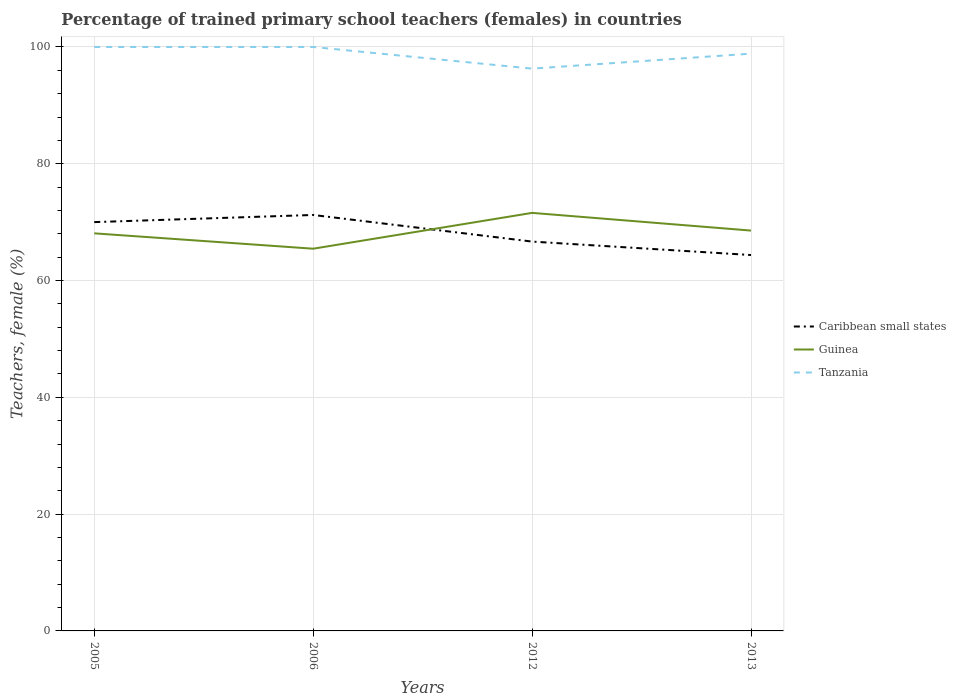Across all years, what is the maximum percentage of trained primary school teachers (females) in Tanzania?
Keep it short and to the point. 96.29. In which year was the percentage of trained primary school teachers (females) in Caribbean small states maximum?
Offer a terse response. 2013. What is the total percentage of trained primary school teachers (females) in Tanzania in the graph?
Provide a short and direct response. 1.14. What is the difference between the highest and the second highest percentage of trained primary school teachers (females) in Tanzania?
Ensure brevity in your answer.  3.71. How many lines are there?
Provide a succinct answer. 3. What is the difference between two consecutive major ticks on the Y-axis?
Give a very brief answer. 20. Are the values on the major ticks of Y-axis written in scientific E-notation?
Offer a terse response. No. Does the graph contain any zero values?
Provide a succinct answer. No. Does the graph contain grids?
Your response must be concise. Yes. How many legend labels are there?
Make the answer very short. 3. How are the legend labels stacked?
Keep it short and to the point. Vertical. What is the title of the graph?
Offer a very short reply. Percentage of trained primary school teachers (females) in countries. What is the label or title of the X-axis?
Provide a short and direct response. Years. What is the label or title of the Y-axis?
Offer a terse response. Teachers, female (%). What is the Teachers, female (%) of Caribbean small states in 2005?
Offer a terse response. 70.01. What is the Teachers, female (%) of Guinea in 2005?
Your answer should be compact. 68.08. What is the Teachers, female (%) in Tanzania in 2005?
Give a very brief answer. 100. What is the Teachers, female (%) of Caribbean small states in 2006?
Offer a very short reply. 71.23. What is the Teachers, female (%) in Guinea in 2006?
Your answer should be compact. 65.45. What is the Teachers, female (%) in Caribbean small states in 2012?
Offer a very short reply. 66.67. What is the Teachers, female (%) in Guinea in 2012?
Provide a succinct answer. 71.59. What is the Teachers, female (%) in Tanzania in 2012?
Your response must be concise. 96.29. What is the Teachers, female (%) in Caribbean small states in 2013?
Provide a succinct answer. 64.37. What is the Teachers, female (%) in Guinea in 2013?
Your answer should be very brief. 68.56. What is the Teachers, female (%) of Tanzania in 2013?
Provide a short and direct response. 98.86. Across all years, what is the maximum Teachers, female (%) in Caribbean small states?
Offer a terse response. 71.23. Across all years, what is the maximum Teachers, female (%) of Guinea?
Offer a very short reply. 71.59. Across all years, what is the minimum Teachers, female (%) in Caribbean small states?
Your answer should be compact. 64.37. Across all years, what is the minimum Teachers, female (%) in Guinea?
Your response must be concise. 65.45. Across all years, what is the minimum Teachers, female (%) of Tanzania?
Your answer should be compact. 96.29. What is the total Teachers, female (%) of Caribbean small states in the graph?
Offer a terse response. 272.29. What is the total Teachers, female (%) in Guinea in the graph?
Provide a succinct answer. 273.69. What is the total Teachers, female (%) in Tanzania in the graph?
Make the answer very short. 395.15. What is the difference between the Teachers, female (%) in Caribbean small states in 2005 and that in 2006?
Keep it short and to the point. -1.22. What is the difference between the Teachers, female (%) of Guinea in 2005 and that in 2006?
Give a very brief answer. 2.63. What is the difference between the Teachers, female (%) in Tanzania in 2005 and that in 2006?
Offer a terse response. 0. What is the difference between the Teachers, female (%) of Caribbean small states in 2005 and that in 2012?
Make the answer very short. 3.33. What is the difference between the Teachers, female (%) in Guinea in 2005 and that in 2012?
Keep it short and to the point. -3.5. What is the difference between the Teachers, female (%) of Tanzania in 2005 and that in 2012?
Provide a short and direct response. 3.71. What is the difference between the Teachers, female (%) of Caribbean small states in 2005 and that in 2013?
Provide a succinct answer. 5.64. What is the difference between the Teachers, female (%) in Guinea in 2005 and that in 2013?
Your answer should be very brief. -0.47. What is the difference between the Teachers, female (%) in Tanzania in 2005 and that in 2013?
Provide a short and direct response. 1.14. What is the difference between the Teachers, female (%) of Caribbean small states in 2006 and that in 2012?
Provide a short and direct response. 4.56. What is the difference between the Teachers, female (%) of Guinea in 2006 and that in 2012?
Your response must be concise. -6.13. What is the difference between the Teachers, female (%) in Tanzania in 2006 and that in 2012?
Ensure brevity in your answer.  3.71. What is the difference between the Teachers, female (%) in Caribbean small states in 2006 and that in 2013?
Offer a very short reply. 6.86. What is the difference between the Teachers, female (%) in Guinea in 2006 and that in 2013?
Provide a succinct answer. -3.1. What is the difference between the Teachers, female (%) of Tanzania in 2006 and that in 2013?
Make the answer very short. 1.14. What is the difference between the Teachers, female (%) in Caribbean small states in 2012 and that in 2013?
Ensure brevity in your answer.  2.3. What is the difference between the Teachers, female (%) of Guinea in 2012 and that in 2013?
Ensure brevity in your answer.  3.03. What is the difference between the Teachers, female (%) in Tanzania in 2012 and that in 2013?
Provide a succinct answer. -2.57. What is the difference between the Teachers, female (%) of Caribbean small states in 2005 and the Teachers, female (%) of Guinea in 2006?
Offer a terse response. 4.55. What is the difference between the Teachers, female (%) in Caribbean small states in 2005 and the Teachers, female (%) in Tanzania in 2006?
Make the answer very short. -29.99. What is the difference between the Teachers, female (%) of Guinea in 2005 and the Teachers, female (%) of Tanzania in 2006?
Provide a succinct answer. -31.92. What is the difference between the Teachers, female (%) of Caribbean small states in 2005 and the Teachers, female (%) of Guinea in 2012?
Keep it short and to the point. -1.58. What is the difference between the Teachers, female (%) of Caribbean small states in 2005 and the Teachers, female (%) of Tanzania in 2012?
Give a very brief answer. -26.28. What is the difference between the Teachers, female (%) in Guinea in 2005 and the Teachers, female (%) in Tanzania in 2012?
Ensure brevity in your answer.  -28.21. What is the difference between the Teachers, female (%) of Caribbean small states in 2005 and the Teachers, female (%) of Guinea in 2013?
Make the answer very short. 1.45. What is the difference between the Teachers, female (%) of Caribbean small states in 2005 and the Teachers, female (%) of Tanzania in 2013?
Offer a terse response. -28.85. What is the difference between the Teachers, female (%) in Guinea in 2005 and the Teachers, female (%) in Tanzania in 2013?
Your answer should be compact. -30.77. What is the difference between the Teachers, female (%) in Caribbean small states in 2006 and the Teachers, female (%) in Guinea in 2012?
Your answer should be compact. -0.36. What is the difference between the Teachers, female (%) in Caribbean small states in 2006 and the Teachers, female (%) in Tanzania in 2012?
Your answer should be compact. -25.06. What is the difference between the Teachers, female (%) in Guinea in 2006 and the Teachers, female (%) in Tanzania in 2012?
Offer a very short reply. -30.84. What is the difference between the Teachers, female (%) of Caribbean small states in 2006 and the Teachers, female (%) of Guinea in 2013?
Your response must be concise. 2.67. What is the difference between the Teachers, female (%) in Caribbean small states in 2006 and the Teachers, female (%) in Tanzania in 2013?
Your answer should be compact. -27.62. What is the difference between the Teachers, female (%) in Guinea in 2006 and the Teachers, female (%) in Tanzania in 2013?
Your response must be concise. -33.4. What is the difference between the Teachers, female (%) in Caribbean small states in 2012 and the Teachers, female (%) in Guinea in 2013?
Offer a very short reply. -1.88. What is the difference between the Teachers, female (%) in Caribbean small states in 2012 and the Teachers, female (%) in Tanzania in 2013?
Provide a short and direct response. -32.18. What is the difference between the Teachers, female (%) of Guinea in 2012 and the Teachers, female (%) of Tanzania in 2013?
Provide a short and direct response. -27.27. What is the average Teachers, female (%) in Caribbean small states per year?
Your answer should be very brief. 68.07. What is the average Teachers, female (%) in Guinea per year?
Provide a succinct answer. 68.42. What is the average Teachers, female (%) in Tanzania per year?
Ensure brevity in your answer.  98.79. In the year 2005, what is the difference between the Teachers, female (%) of Caribbean small states and Teachers, female (%) of Guinea?
Offer a very short reply. 1.92. In the year 2005, what is the difference between the Teachers, female (%) in Caribbean small states and Teachers, female (%) in Tanzania?
Your answer should be compact. -29.99. In the year 2005, what is the difference between the Teachers, female (%) in Guinea and Teachers, female (%) in Tanzania?
Provide a succinct answer. -31.92. In the year 2006, what is the difference between the Teachers, female (%) of Caribbean small states and Teachers, female (%) of Guinea?
Your answer should be very brief. 5.78. In the year 2006, what is the difference between the Teachers, female (%) of Caribbean small states and Teachers, female (%) of Tanzania?
Give a very brief answer. -28.77. In the year 2006, what is the difference between the Teachers, female (%) of Guinea and Teachers, female (%) of Tanzania?
Provide a short and direct response. -34.55. In the year 2012, what is the difference between the Teachers, female (%) of Caribbean small states and Teachers, female (%) of Guinea?
Offer a terse response. -4.92. In the year 2012, what is the difference between the Teachers, female (%) of Caribbean small states and Teachers, female (%) of Tanzania?
Ensure brevity in your answer.  -29.62. In the year 2012, what is the difference between the Teachers, female (%) in Guinea and Teachers, female (%) in Tanzania?
Offer a very short reply. -24.7. In the year 2013, what is the difference between the Teachers, female (%) of Caribbean small states and Teachers, female (%) of Guinea?
Your answer should be very brief. -4.19. In the year 2013, what is the difference between the Teachers, female (%) of Caribbean small states and Teachers, female (%) of Tanzania?
Offer a terse response. -34.49. In the year 2013, what is the difference between the Teachers, female (%) in Guinea and Teachers, female (%) in Tanzania?
Keep it short and to the point. -30.3. What is the ratio of the Teachers, female (%) in Caribbean small states in 2005 to that in 2006?
Your answer should be compact. 0.98. What is the ratio of the Teachers, female (%) of Guinea in 2005 to that in 2006?
Keep it short and to the point. 1.04. What is the ratio of the Teachers, female (%) in Caribbean small states in 2005 to that in 2012?
Provide a succinct answer. 1.05. What is the ratio of the Teachers, female (%) of Guinea in 2005 to that in 2012?
Make the answer very short. 0.95. What is the ratio of the Teachers, female (%) in Caribbean small states in 2005 to that in 2013?
Provide a succinct answer. 1.09. What is the ratio of the Teachers, female (%) of Tanzania in 2005 to that in 2013?
Your answer should be compact. 1.01. What is the ratio of the Teachers, female (%) of Caribbean small states in 2006 to that in 2012?
Your answer should be very brief. 1.07. What is the ratio of the Teachers, female (%) of Guinea in 2006 to that in 2012?
Provide a short and direct response. 0.91. What is the ratio of the Teachers, female (%) in Tanzania in 2006 to that in 2012?
Your response must be concise. 1.04. What is the ratio of the Teachers, female (%) in Caribbean small states in 2006 to that in 2013?
Provide a succinct answer. 1.11. What is the ratio of the Teachers, female (%) of Guinea in 2006 to that in 2013?
Offer a terse response. 0.95. What is the ratio of the Teachers, female (%) of Tanzania in 2006 to that in 2013?
Provide a short and direct response. 1.01. What is the ratio of the Teachers, female (%) in Caribbean small states in 2012 to that in 2013?
Offer a terse response. 1.04. What is the ratio of the Teachers, female (%) in Guinea in 2012 to that in 2013?
Make the answer very short. 1.04. What is the difference between the highest and the second highest Teachers, female (%) in Caribbean small states?
Your answer should be very brief. 1.22. What is the difference between the highest and the second highest Teachers, female (%) in Guinea?
Offer a very short reply. 3.03. What is the difference between the highest and the second highest Teachers, female (%) in Tanzania?
Offer a terse response. 0. What is the difference between the highest and the lowest Teachers, female (%) in Caribbean small states?
Give a very brief answer. 6.86. What is the difference between the highest and the lowest Teachers, female (%) in Guinea?
Make the answer very short. 6.13. What is the difference between the highest and the lowest Teachers, female (%) in Tanzania?
Provide a short and direct response. 3.71. 